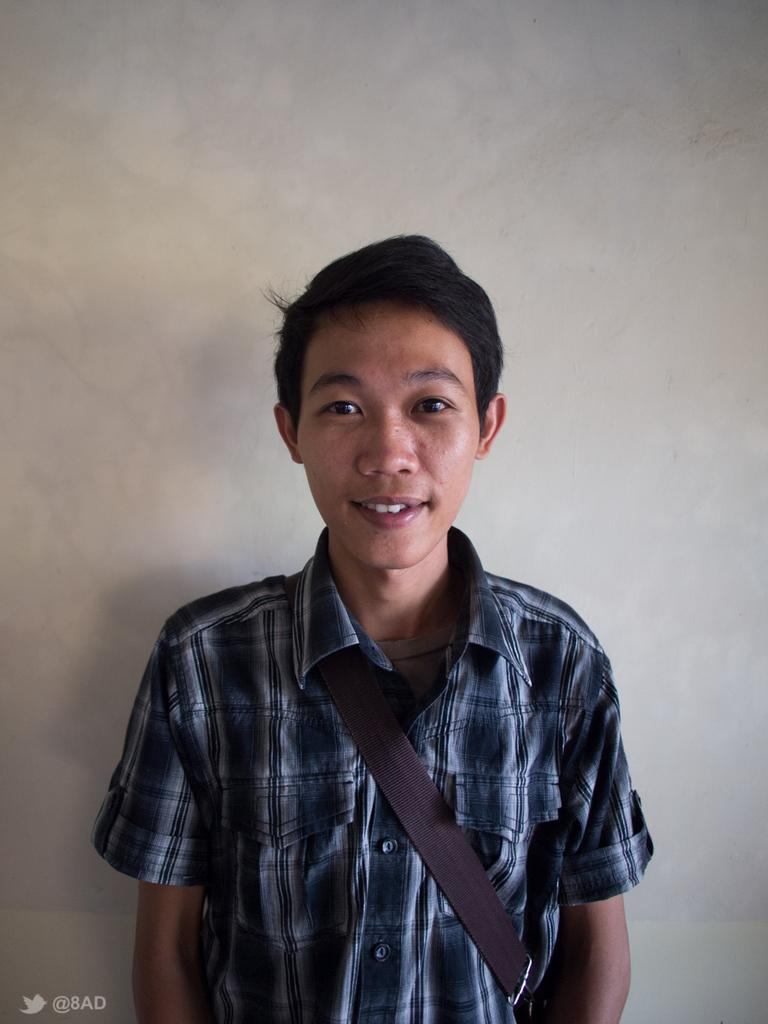Who or what is the main subject in the image? There is a person in the image. What is behind the person in the image? The person is in front of a wall. What can be observed about the person's attire? The person is wearing clothes. How many toes can be seen on the person's feet in the image? There is no information about the person's feet or toes in the image, so it cannot be determined. 